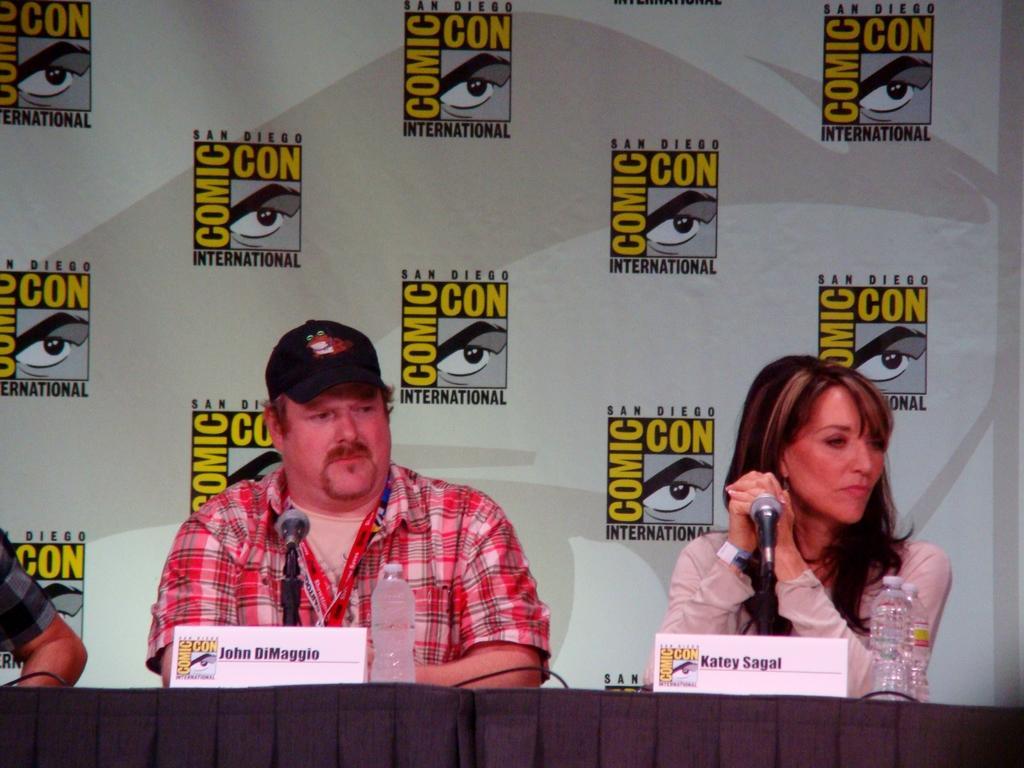Could you give a brief overview of what you see in this image? Here in this picture we can see a man and a woman sitting over a place and in front of them we can see a table, on which we can see name cards and bottles present and we can also see microphone present on the table and the man is wearing cap and behind them we can see a banner present. 